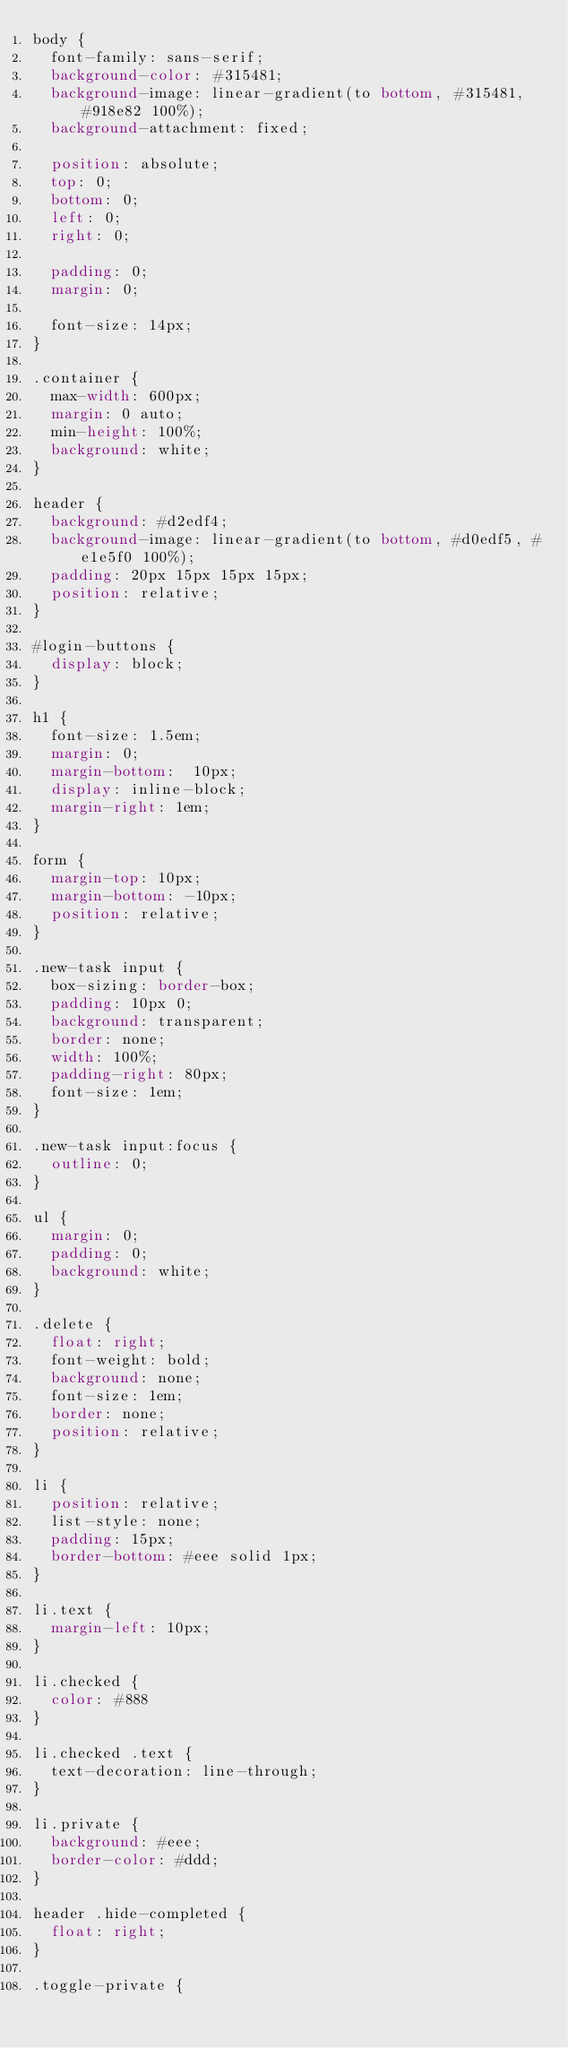Convert code to text. <code><loc_0><loc_0><loc_500><loc_500><_CSS_>body {
  font-family: sans-serif;
  background-color: #315481;
  background-image: linear-gradient(to bottom, #315481, #918e82 100%);
  background-attachment: fixed;
  
  position: absolute;
  top: 0;
  bottom: 0;
  left: 0;
  right: 0;

  padding: 0;
  margin: 0;

  font-size: 14px;
}

.container {
  max-width: 600px;
  margin: 0 auto;
  min-height: 100%;
  background: white;
}

header {
  background: #d2edf4;
  background-image: linear-gradient(to bottom, #d0edf5, #e1e5f0 100%);
  padding: 20px 15px 15px 15px;
  position: relative;
}

#login-buttons {
  display: block;
}

h1 {
  font-size: 1.5em;
  margin: 0;
  margin-bottom:  10px;
  display: inline-block;
  margin-right: 1em;
}

form {
  margin-top: 10px;
  margin-bottom: -10px;
  position: relative;
}

.new-task input {
  box-sizing: border-box;
  padding: 10px 0;
  background: transparent;
  border: none;
  width: 100%;
  padding-right: 80px;
  font-size: 1em;
}

.new-task input:focus {
  outline: 0;
}

ul {
  margin: 0;
  padding: 0;
  background: white;
}

.delete {
  float: right;
  font-weight: bold;
  background: none;
  font-size: 1em;
  border: none;
  position: relative;
}

li {
  position: relative;
  list-style: none;
  padding: 15px;
  border-bottom: #eee solid 1px;
}

li.text {
  margin-left: 10px;
}

li.checked {
  color: #888
}

li.checked .text {
  text-decoration: line-through;
}

li.private {
  background: #eee;
  border-color: #ddd;
}

header .hide-completed {
  float: right;
}

.toggle-private {</code> 